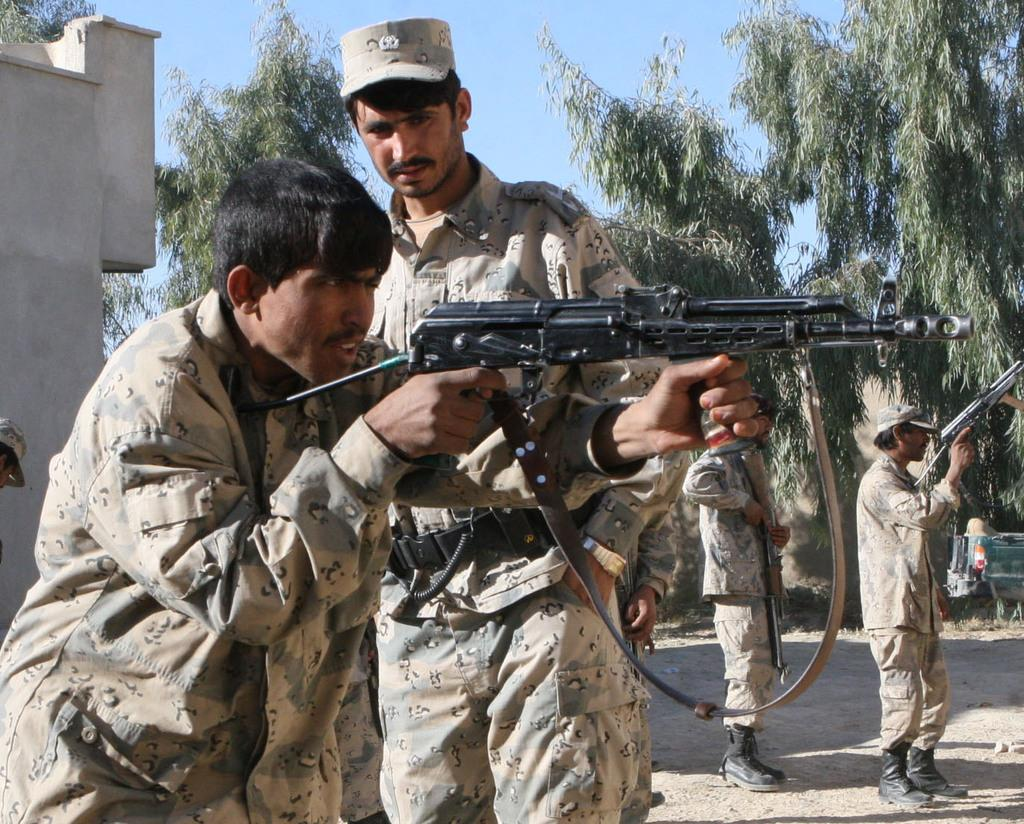How many people are in the image? There are people in the image, but the exact number is not specified. What are some of the people holding in the image? Some of the people are holding guns in the image. What can be seen in the background of the image? There are trees, a wall, and the sky visible in the background of the image. What color crayon is being used by the person in the image? There is no crayon present in the image, so it is not possible to determine the color of a crayon being used. 